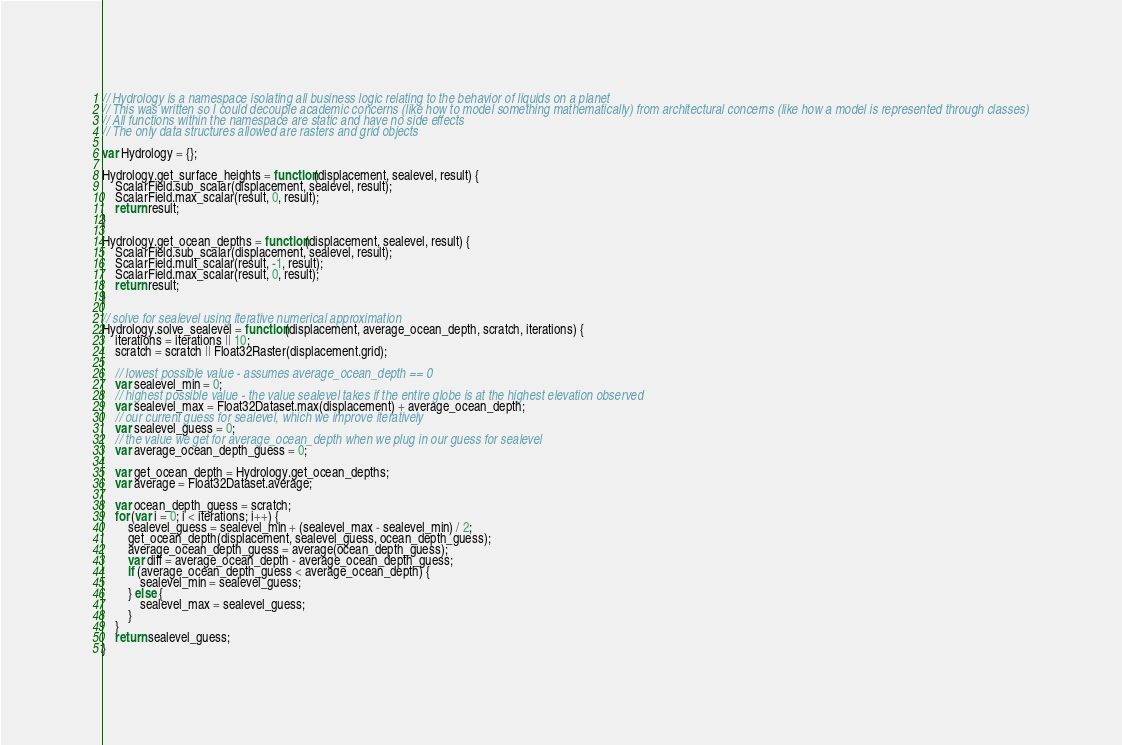<code> <loc_0><loc_0><loc_500><loc_500><_JavaScript_>// Hydrology is a namespace isolating all business logic relating to the behavior of liquids on a planet
// This was written so I could decouple academic concerns (like how to model something mathematically) from architectural concerns (like how a model is represented through classes)
// All functions within the namespace are static and have no side effects
// The only data structures allowed are rasters and grid objects

var Hydrology = {};

Hydrology.get_surface_heights = function(displacement, sealevel, result) {
    ScalarField.sub_scalar(displacement, sealevel, result);
    ScalarField.max_scalar(result, 0, result);
    return result;
}

Hydrology.get_ocean_depths = function(displacement, sealevel, result) {
    ScalarField.sub_scalar(displacement, sealevel, result);
    ScalarField.mult_scalar(result, -1, result);
    ScalarField.max_scalar(result, 0, result);
    return result;
}

// solve for sealevel using iterative numerical approximation
Hydrology.solve_sealevel = function(displacement, average_ocean_depth, scratch, iterations) {
    iterations = iterations || 10;
    scratch = scratch || Float32Raster(displacement.grid);

    // lowest possible value - assumes average_ocean_depth == 0
    var sealevel_min = 0;
    // highest possible value - the value sealevel takes if the entire globe is at the highest elevation observed
    var sealevel_max = Float32Dataset.max(displacement) + average_ocean_depth; 
    // our current guess for sealevel, which we improve iteratively
    var sealevel_guess = 0;
    // the value we get for average_ocean_depth when we plug in our guess for sealevel
    var average_ocean_depth_guess = 0;

    var get_ocean_depth = Hydrology.get_ocean_depths;
    var average = Float32Dataset.average;

    var ocean_depth_guess = scratch;
    for (var i = 0; i < iterations; i++) {
        sealevel_guess = sealevel_min + (sealevel_max - sealevel_min) / 2;
        get_ocean_depth(displacement, sealevel_guess, ocean_depth_guess);
        average_ocean_depth_guess = average(ocean_depth_guess);
        var diff = average_ocean_depth - average_ocean_depth_guess;
        if (average_ocean_depth_guess < average_ocean_depth) {
            sealevel_min = sealevel_guess;
        } else {
            sealevel_max = sealevel_guess;
        }
    }
    return sealevel_guess;
}
</code> 